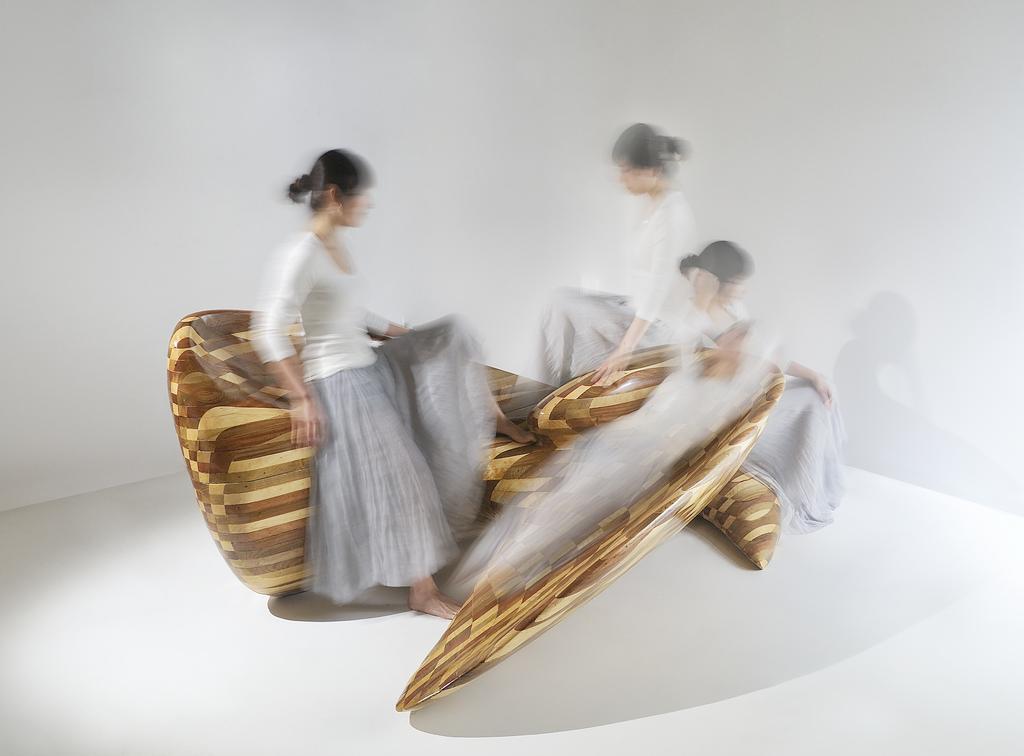Describe this image in one or two sentences. In this image we can see people are sitting on a wooden chair. Here we can see floor. In the background there is a wall. 